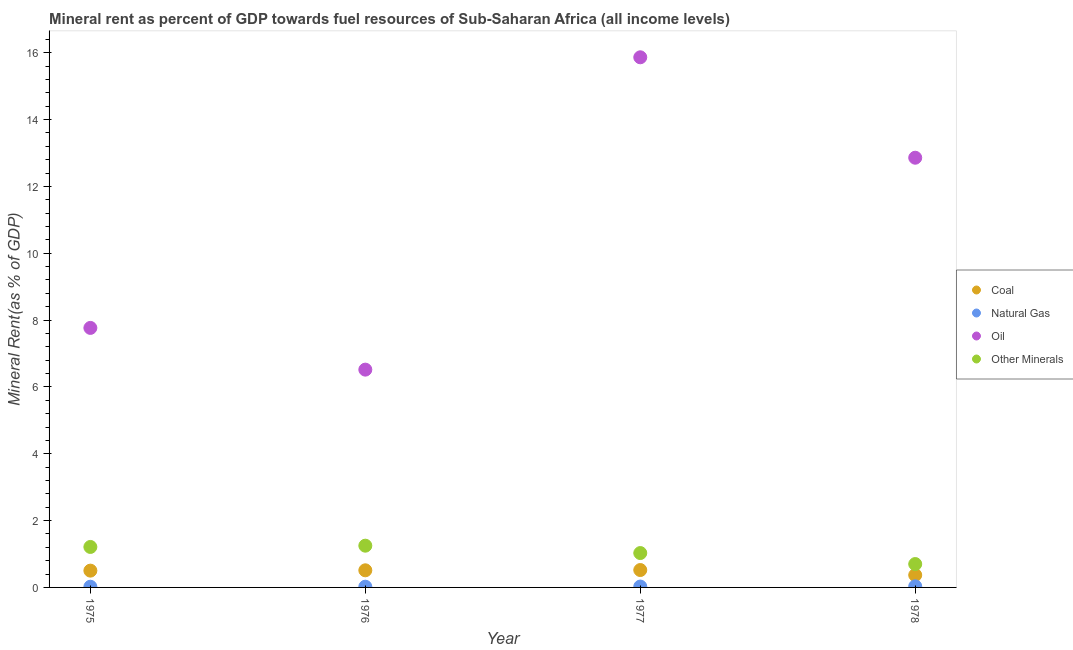How many different coloured dotlines are there?
Provide a short and direct response. 4. What is the coal rent in 1977?
Keep it short and to the point. 0.52. Across all years, what is the maximum natural gas rent?
Offer a very short reply. 0.03. Across all years, what is the minimum oil rent?
Ensure brevity in your answer.  6.52. In which year was the  rent of other minerals maximum?
Give a very brief answer. 1976. In which year was the natural gas rent minimum?
Give a very brief answer. 1975. What is the total natural gas rent in the graph?
Your answer should be compact. 0.1. What is the difference between the natural gas rent in 1975 and that in 1976?
Your answer should be very brief. -0. What is the difference between the natural gas rent in 1975 and the  rent of other minerals in 1977?
Your answer should be very brief. -1.01. What is the average  rent of other minerals per year?
Make the answer very short. 1.05. In the year 1976, what is the difference between the oil rent and natural gas rent?
Keep it short and to the point. 6.5. What is the ratio of the coal rent in 1976 to that in 1977?
Make the answer very short. 0.98. Is the difference between the oil rent in 1977 and 1978 greater than the difference between the coal rent in 1977 and 1978?
Your answer should be compact. Yes. What is the difference between the highest and the second highest  rent of other minerals?
Offer a terse response. 0.04. What is the difference between the highest and the lowest oil rent?
Your answer should be compact. 9.35. Is it the case that in every year, the sum of the coal rent and natural gas rent is greater than the oil rent?
Give a very brief answer. No. Does the natural gas rent monotonically increase over the years?
Offer a very short reply. Yes. Is the natural gas rent strictly greater than the  rent of other minerals over the years?
Your response must be concise. No. Is the natural gas rent strictly less than the oil rent over the years?
Ensure brevity in your answer.  Yes. How are the legend labels stacked?
Make the answer very short. Vertical. What is the title of the graph?
Provide a short and direct response. Mineral rent as percent of GDP towards fuel resources of Sub-Saharan Africa (all income levels). Does "Miscellaneous expenses" appear as one of the legend labels in the graph?
Make the answer very short. No. What is the label or title of the Y-axis?
Your answer should be very brief. Mineral Rent(as % of GDP). What is the Mineral Rent(as % of GDP) in Coal in 1975?
Provide a succinct answer. 0.5. What is the Mineral Rent(as % of GDP) in Natural Gas in 1975?
Provide a succinct answer. 0.02. What is the Mineral Rent(as % of GDP) in Oil in 1975?
Give a very brief answer. 7.77. What is the Mineral Rent(as % of GDP) in Other Minerals in 1975?
Provide a short and direct response. 1.21. What is the Mineral Rent(as % of GDP) in Coal in 1976?
Provide a succinct answer. 0.51. What is the Mineral Rent(as % of GDP) in Natural Gas in 1976?
Offer a very short reply. 0.02. What is the Mineral Rent(as % of GDP) of Oil in 1976?
Provide a succinct answer. 6.52. What is the Mineral Rent(as % of GDP) in Other Minerals in 1976?
Offer a terse response. 1.25. What is the Mineral Rent(as % of GDP) in Coal in 1977?
Ensure brevity in your answer.  0.52. What is the Mineral Rent(as % of GDP) of Natural Gas in 1977?
Give a very brief answer. 0.03. What is the Mineral Rent(as % of GDP) in Oil in 1977?
Your response must be concise. 15.86. What is the Mineral Rent(as % of GDP) of Other Minerals in 1977?
Offer a terse response. 1.03. What is the Mineral Rent(as % of GDP) in Coal in 1978?
Offer a very short reply. 0.37. What is the Mineral Rent(as % of GDP) of Natural Gas in 1978?
Provide a short and direct response. 0.03. What is the Mineral Rent(as % of GDP) in Oil in 1978?
Offer a terse response. 12.86. What is the Mineral Rent(as % of GDP) of Other Minerals in 1978?
Provide a short and direct response. 0.7. Across all years, what is the maximum Mineral Rent(as % of GDP) in Coal?
Offer a terse response. 0.52. Across all years, what is the maximum Mineral Rent(as % of GDP) of Natural Gas?
Your answer should be compact. 0.03. Across all years, what is the maximum Mineral Rent(as % of GDP) in Oil?
Your response must be concise. 15.86. Across all years, what is the maximum Mineral Rent(as % of GDP) in Other Minerals?
Offer a terse response. 1.25. Across all years, what is the minimum Mineral Rent(as % of GDP) in Coal?
Your answer should be compact. 0.37. Across all years, what is the minimum Mineral Rent(as % of GDP) of Natural Gas?
Your response must be concise. 0.02. Across all years, what is the minimum Mineral Rent(as % of GDP) in Oil?
Provide a short and direct response. 6.52. Across all years, what is the minimum Mineral Rent(as % of GDP) of Other Minerals?
Your answer should be compact. 0.7. What is the total Mineral Rent(as % of GDP) of Coal in the graph?
Provide a succinct answer. 1.9. What is the total Mineral Rent(as % of GDP) in Natural Gas in the graph?
Offer a very short reply. 0.1. What is the total Mineral Rent(as % of GDP) of Oil in the graph?
Give a very brief answer. 43.01. What is the total Mineral Rent(as % of GDP) in Other Minerals in the graph?
Offer a very short reply. 4.19. What is the difference between the Mineral Rent(as % of GDP) of Coal in 1975 and that in 1976?
Provide a short and direct response. -0.01. What is the difference between the Mineral Rent(as % of GDP) in Natural Gas in 1975 and that in 1976?
Your answer should be very brief. -0. What is the difference between the Mineral Rent(as % of GDP) in Oil in 1975 and that in 1976?
Give a very brief answer. 1.25. What is the difference between the Mineral Rent(as % of GDP) of Other Minerals in 1975 and that in 1976?
Offer a very short reply. -0.04. What is the difference between the Mineral Rent(as % of GDP) in Coal in 1975 and that in 1977?
Provide a succinct answer. -0.02. What is the difference between the Mineral Rent(as % of GDP) in Natural Gas in 1975 and that in 1977?
Offer a terse response. -0.01. What is the difference between the Mineral Rent(as % of GDP) of Oil in 1975 and that in 1977?
Your answer should be compact. -8.1. What is the difference between the Mineral Rent(as % of GDP) in Other Minerals in 1975 and that in 1977?
Offer a terse response. 0.18. What is the difference between the Mineral Rent(as % of GDP) in Coal in 1975 and that in 1978?
Give a very brief answer. 0.13. What is the difference between the Mineral Rent(as % of GDP) of Natural Gas in 1975 and that in 1978?
Offer a terse response. -0.01. What is the difference between the Mineral Rent(as % of GDP) in Oil in 1975 and that in 1978?
Your answer should be compact. -5.09. What is the difference between the Mineral Rent(as % of GDP) in Other Minerals in 1975 and that in 1978?
Provide a short and direct response. 0.51. What is the difference between the Mineral Rent(as % of GDP) in Coal in 1976 and that in 1977?
Keep it short and to the point. -0.01. What is the difference between the Mineral Rent(as % of GDP) in Natural Gas in 1976 and that in 1977?
Keep it short and to the point. -0. What is the difference between the Mineral Rent(as % of GDP) in Oil in 1976 and that in 1977?
Offer a very short reply. -9.35. What is the difference between the Mineral Rent(as % of GDP) in Other Minerals in 1976 and that in 1977?
Your answer should be compact. 0.22. What is the difference between the Mineral Rent(as % of GDP) of Coal in 1976 and that in 1978?
Offer a very short reply. 0.14. What is the difference between the Mineral Rent(as % of GDP) of Natural Gas in 1976 and that in 1978?
Provide a short and direct response. -0.01. What is the difference between the Mineral Rent(as % of GDP) of Oil in 1976 and that in 1978?
Provide a succinct answer. -6.34. What is the difference between the Mineral Rent(as % of GDP) of Other Minerals in 1976 and that in 1978?
Ensure brevity in your answer.  0.55. What is the difference between the Mineral Rent(as % of GDP) of Coal in 1977 and that in 1978?
Offer a very short reply. 0.15. What is the difference between the Mineral Rent(as % of GDP) in Natural Gas in 1977 and that in 1978?
Offer a terse response. -0.01. What is the difference between the Mineral Rent(as % of GDP) in Oil in 1977 and that in 1978?
Give a very brief answer. 3.01. What is the difference between the Mineral Rent(as % of GDP) in Other Minerals in 1977 and that in 1978?
Provide a succinct answer. 0.33. What is the difference between the Mineral Rent(as % of GDP) in Coal in 1975 and the Mineral Rent(as % of GDP) in Natural Gas in 1976?
Offer a very short reply. 0.48. What is the difference between the Mineral Rent(as % of GDP) in Coal in 1975 and the Mineral Rent(as % of GDP) in Oil in 1976?
Provide a succinct answer. -6.02. What is the difference between the Mineral Rent(as % of GDP) of Coal in 1975 and the Mineral Rent(as % of GDP) of Other Minerals in 1976?
Provide a succinct answer. -0.75. What is the difference between the Mineral Rent(as % of GDP) in Natural Gas in 1975 and the Mineral Rent(as % of GDP) in Oil in 1976?
Make the answer very short. -6.5. What is the difference between the Mineral Rent(as % of GDP) of Natural Gas in 1975 and the Mineral Rent(as % of GDP) of Other Minerals in 1976?
Ensure brevity in your answer.  -1.23. What is the difference between the Mineral Rent(as % of GDP) of Oil in 1975 and the Mineral Rent(as % of GDP) of Other Minerals in 1976?
Your answer should be very brief. 6.52. What is the difference between the Mineral Rent(as % of GDP) in Coal in 1975 and the Mineral Rent(as % of GDP) in Natural Gas in 1977?
Offer a very short reply. 0.48. What is the difference between the Mineral Rent(as % of GDP) of Coal in 1975 and the Mineral Rent(as % of GDP) of Oil in 1977?
Ensure brevity in your answer.  -15.36. What is the difference between the Mineral Rent(as % of GDP) in Coal in 1975 and the Mineral Rent(as % of GDP) in Other Minerals in 1977?
Provide a succinct answer. -0.53. What is the difference between the Mineral Rent(as % of GDP) in Natural Gas in 1975 and the Mineral Rent(as % of GDP) in Oil in 1977?
Ensure brevity in your answer.  -15.84. What is the difference between the Mineral Rent(as % of GDP) in Natural Gas in 1975 and the Mineral Rent(as % of GDP) in Other Minerals in 1977?
Give a very brief answer. -1.01. What is the difference between the Mineral Rent(as % of GDP) of Oil in 1975 and the Mineral Rent(as % of GDP) of Other Minerals in 1977?
Provide a succinct answer. 6.74. What is the difference between the Mineral Rent(as % of GDP) in Coal in 1975 and the Mineral Rent(as % of GDP) in Natural Gas in 1978?
Offer a very short reply. 0.47. What is the difference between the Mineral Rent(as % of GDP) of Coal in 1975 and the Mineral Rent(as % of GDP) of Oil in 1978?
Provide a succinct answer. -12.36. What is the difference between the Mineral Rent(as % of GDP) in Coal in 1975 and the Mineral Rent(as % of GDP) in Other Minerals in 1978?
Make the answer very short. -0.2. What is the difference between the Mineral Rent(as % of GDP) of Natural Gas in 1975 and the Mineral Rent(as % of GDP) of Oil in 1978?
Your response must be concise. -12.84. What is the difference between the Mineral Rent(as % of GDP) in Natural Gas in 1975 and the Mineral Rent(as % of GDP) in Other Minerals in 1978?
Provide a short and direct response. -0.68. What is the difference between the Mineral Rent(as % of GDP) in Oil in 1975 and the Mineral Rent(as % of GDP) in Other Minerals in 1978?
Your answer should be compact. 7.07. What is the difference between the Mineral Rent(as % of GDP) in Coal in 1976 and the Mineral Rent(as % of GDP) in Natural Gas in 1977?
Ensure brevity in your answer.  0.49. What is the difference between the Mineral Rent(as % of GDP) in Coal in 1976 and the Mineral Rent(as % of GDP) in Oil in 1977?
Provide a short and direct response. -15.35. What is the difference between the Mineral Rent(as % of GDP) of Coal in 1976 and the Mineral Rent(as % of GDP) of Other Minerals in 1977?
Your answer should be very brief. -0.52. What is the difference between the Mineral Rent(as % of GDP) of Natural Gas in 1976 and the Mineral Rent(as % of GDP) of Oil in 1977?
Offer a terse response. -15.84. What is the difference between the Mineral Rent(as % of GDP) of Natural Gas in 1976 and the Mineral Rent(as % of GDP) of Other Minerals in 1977?
Make the answer very short. -1.01. What is the difference between the Mineral Rent(as % of GDP) of Oil in 1976 and the Mineral Rent(as % of GDP) of Other Minerals in 1977?
Make the answer very short. 5.49. What is the difference between the Mineral Rent(as % of GDP) in Coal in 1976 and the Mineral Rent(as % of GDP) in Natural Gas in 1978?
Your answer should be compact. 0.48. What is the difference between the Mineral Rent(as % of GDP) in Coal in 1976 and the Mineral Rent(as % of GDP) in Oil in 1978?
Make the answer very short. -12.35. What is the difference between the Mineral Rent(as % of GDP) of Coal in 1976 and the Mineral Rent(as % of GDP) of Other Minerals in 1978?
Make the answer very short. -0.19. What is the difference between the Mineral Rent(as % of GDP) in Natural Gas in 1976 and the Mineral Rent(as % of GDP) in Oil in 1978?
Give a very brief answer. -12.84. What is the difference between the Mineral Rent(as % of GDP) in Natural Gas in 1976 and the Mineral Rent(as % of GDP) in Other Minerals in 1978?
Provide a succinct answer. -0.68. What is the difference between the Mineral Rent(as % of GDP) of Oil in 1976 and the Mineral Rent(as % of GDP) of Other Minerals in 1978?
Provide a succinct answer. 5.82. What is the difference between the Mineral Rent(as % of GDP) of Coal in 1977 and the Mineral Rent(as % of GDP) of Natural Gas in 1978?
Ensure brevity in your answer.  0.49. What is the difference between the Mineral Rent(as % of GDP) in Coal in 1977 and the Mineral Rent(as % of GDP) in Oil in 1978?
Ensure brevity in your answer.  -12.34. What is the difference between the Mineral Rent(as % of GDP) in Coal in 1977 and the Mineral Rent(as % of GDP) in Other Minerals in 1978?
Your answer should be compact. -0.18. What is the difference between the Mineral Rent(as % of GDP) in Natural Gas in 1977 and the Mineral Rent(as % of GDP) in Oil in 1978?
Your response must be concise. -12.83. What is the difference between the Mineral Rent(as % of GDP) in Natural Gas in 1977 and the Mineral Rent(as % of GDP) in Other Minerals in 1978?
Provide a succinct answer. -0.67. What is the difference between the Mineral Rent(as % of GDP) of Oil in 1977 and the Mineral Rent(as % of GDP) of Other Minerals in 1978?
Your response must be concise. 15.16. What is the average Mineral Rent(as % of GDP) in Coal per year?
Your response must be concise. 0.48. What is the average Mineral Rent(as % of GDP) of Natural Gas per year?
Offer a terse response. 0.03. What is the average Mineral Rent(as % of GDP) in Oil per year?
Give a very brief answer. 10.75. What is the average Mineral Rent(as % of GDP) in Other Minerals per year?
Give a very brief answer. 1.05. In the year 1975, what is the difference between the Mineral Rent(as % of GDP) in Coal and Mineral Rent(as % of GDP) in Natural Gas?
Your answer should be very brief. 0.48. In the year 1975, what is the difference between the Mineral Rent(as % of GDP) in Coal and Mineral Rent(as % of GDP) in Oil?
Offer a terse response. -7.26. In the year 1975, what is the difference between the Mineral Rent(as % of GDP) of Coal and Mineral Rent(as % of GDP) of Other Minerals?
Make the answer very short. -0.71. In the year 1975, what is the difference between the Mineral Rent(as % of GDP) of Natural Gas and Mineral Rent(as % of GDP) of Oil?
Offer a very short reply. -7.75. In the year 1975, what is the difference between the Mineral Rent(as % of GDP) in Natural Gas and Mineral Rent(as % of GDP) in Other Minerals?
Keep it short and to the point. -1.19. In the year 1975, what is the difference between the Mineral Rent(as % of GDP) in Oil and Mineral Rent(as % of GDP) in Other Minerals?
Your answer should be compact. 6.55. In the year 1976, what is the difference between the Mineral Rent(as % of GDP) of Coal and Mineral Rent(as % of GDP) of Natural Gas?
Keep it short and to the point. 0.49. In the year 1976, what is the difference between the Mineral Rent(as % of GDP) of Coal and Mineral Rent(as % of GDP) of Oil?
Your answer should be very brief. -6. In the year 1976, what is the difference between the Mineral Rent(as % of GDP) of Coal and Mineral Rent(as % of GDP) of Other Minerals?
Make the answer very short. -0.74. In the year 1976, what is the difference between the Mineral Rent(as % of GDP) of Natural Gas and Mineral Rent(as % of GDP) of Oil?
Ensure brevity in your answer.  -6.5. In the year 1976, what is the difference between the Mineral Rent(as % of GDP) in Natural Gas and Mineral Rent(as % of GDP) in Other Minerals?
Your answer should be compact. -1.23. In the year 1976, what is the difference between the Mineral Rent(as % of GDP) in Oil and Mineral Rent(as % of GDP) in Other Minerals?
Provide a short and direct response. 5.27. In the year 1977, what is the difference between the Mineral Rent(as % of GDP) in Coal and Mineral Rent(as % of GDP) in Natural Gas?
Your answer should be compact. 0.49. In the year 1977, what is the difference between the Mineral Rent(as % of GDP) in Coal and Mineral Rent(as % of GDP) in Oil?
Give a very brief answer. -15.34. In the year 1977, what is the difference between the Mineral Rent(as % of GDP) in Coal and Mineral Rent(as % of GDP) in Other Minerals?
Your answer should be very brief. -0.51. In the year 1977, what is the difference between the Mineral Rent(as % of GDP) of Natural Gas and Mineral Rent(as % of GDP) of Oil?
Provide a short and direct response. -15.84. In the year 1977, what is the difference between the Mineral Rent(as % of GDP) in Natural Gas and Mineral Rent(as % of GDP) in Other Minerals?
Provide a short and direct response. -1. In the year 1977, what is the difference between the Mineral Rent(as % of GDP) in Oil and Mineral Rent(as % of GDP) in Other Minerals?
Your response must be concise. 14.84. In the year 1978, what is the difference between the Mineral Rent(as % of GDP) in Coal and Mineral Rent(as % of GDP) in Natural Gas?
Provide a succinct answer. 0.34. In the year 1978, what is the difference between the Mineral Rent(as % of GDP) in Coal and Mineral Rent(as % of GDP) in Oil?
Make the answer very short. -12.49. In the year 1978, what is the difference between the Mineral Rent(as % of GDP) of Coal and Mineral Rent(as % of GDP) of Other Minerals?
Your response must be concise. -0.33. In the year 1978, what is the difference between the Mineral Rent(as % of GDP) of Natural Gas and Mineral Rent(as % of GDP) of Oil?
Your answer should be very brief. -12.83. In the year 1978, what is the difference between the Mineral Rent(as % of GDP) in Natural Gas and Mineral Rent(as % of GDP) in Other Minerals?
Keep it short and to the point. -0.67. In the year 1978, what is the difference between the Mineral Rent(as % of GDP) in Oil and Mineral Rent(as % of GDP) in Other Minerals?
Keep it short and to the point. 12.16. What is the ratio of the Mineral Rent(as % of GDP) in Coal in 1975 to that in 1976?
Give a very brief answer. 0.98. What is the ratio of the Mineral Rent(as % of GDP) of Natural Gas in 1975 to that in 1976?
Ensure brevity in your answer.  0.95. What is the ratio of the Mineral Rent(as % of GDP) in Oil in 1975 to that in 1976?
Give a very brief answer. 1.19. What is the ratio of the Mineral Rent(as % of GDP) in Other Minerals in 1975 to that in 1976?
Provide a succinct answer. 0.97. What is the ratio of the Mineral Rent(as % of GDP) of Coal in 1975 to that in 1977?
Offer a very short reply. 0.97. What is the ratio of the Mineral Rent(as % of GDP) of Natural Gas in 1975 to that in 1977?
Offer a terse response. 0.8. What is the ratio of the Mineral Rent(as % of GDP) in Oil in 1975 to that in 1977?
Provide a short and direct response. 0.49. What is the ratio of the Mineral Rent(as % of GDP) of Other Minerals in 1975 to that in 1977?
Keep it short and to the point. 1.18. What is the ratio of the Mineral Rent(as % of GDP) of Coal in 1975 to that in 1978?
Your answer should be very brief. 1.36. What is the ratio of the Mineral Rent(as % of GDP) in Oil in 1975 to that in 1978?
Offer a terse response. 0.6. What is the ratio of the Mineral Rent(as % of GDP) in Other Minerals in 1975 to that in 1978?
Keep it short and to the point. 1.73. What is the ratio of the Mineral Rent(as % of GDP) in Coal in 1976 to that in 1977?
Your answer should be very brief. 0.98. What is the ratio of the Mineral Rent(as % of GDP) of Natural Gas in 1976 to that in 1977?
Give a very brief answer. 0.84. What is the ratio of the Mineral Rent(as % of GDP) in Oil in 1976 to that in 1977?
Give a very brief answer. 0.41. What is the ratio of the Mineral Rent(as % of GDP) of Other Minerals in 1976 to that in 1977?
Ensure brevity in your answer.  1.21. What is the ratio of the Mineral Rent(as % of GDP) of Coal in 1976 to that in 1978?
Provide a succinct answer. 1.39. What is the ratio of the Mineral Rent(as % of GDP) in Natural Gas in 1976 to that in 1978?
Provide a succinct answer. 0.66. What is the ratio of the Mineral Rent(as % of GDP) in Oil in 1976 to that in 1978?
Make the answer very short. 0.51. What is the ratio of the Mineral Rent(as % of GDP) of Other Minerals in 1976 to that in 1978?
Offer a terse response. 1.79. What is the ratio of the Mineral Rent(as % of GDP) in Coal in 1977 to that in 1978?
Keep it short and to the point. 1.41. What is the ratio of the Mineral Rent(as % of GDP) of Natural Gas in 1977 to that in 1978?
Keep it short and to the point. 0.79. What is the ratio of the Mineral Rent(as % of GDP) in Oil in 1977 to that in 1978?
Your answer should be very brief. 1.23. What is the ratio of the Mineral Rent(as % of GDP) of Other Minerals in 1977 to that in 1978?
Offer a very short reply. 1.47. What is the difference between the highest and the second highest Mineral Rent(as % of GDP) in Coal?
Make the answer very short. 0.01. What is the difference between the highest and the second highest Mineral Rent(as % of GDP) of Natural Gas?
Keep it short and to the point. 0.01. What is the difference between the highest and the second highest Mineral Rent(as % of GDP) in Oil?
Provide a short and direct response. 3.01. What is the difference between the highest and the second highest Mineral Rent(as % of GDP) in Other Minerals?
Give a very brief answer. 0.04. What is the difference between the highest and the lowest Mineral Rent(as % of GDP) in Coal?
Offer a terse response. 0.15. What is the difference between the highest and the lowest Mineral Rent(as % of GDP) in Natural Gas?
Offer a very short reply. 0.01. What is the difference between the highest and the lowest Mineral Rent(as % of GDP) of Oil?
Provide a short and direct response. 9.35. What is the difference between the highest and the lowest Mineral Rent(as % of GDP) in Other Minerals?
Provide a short and direct response. 0.55. 